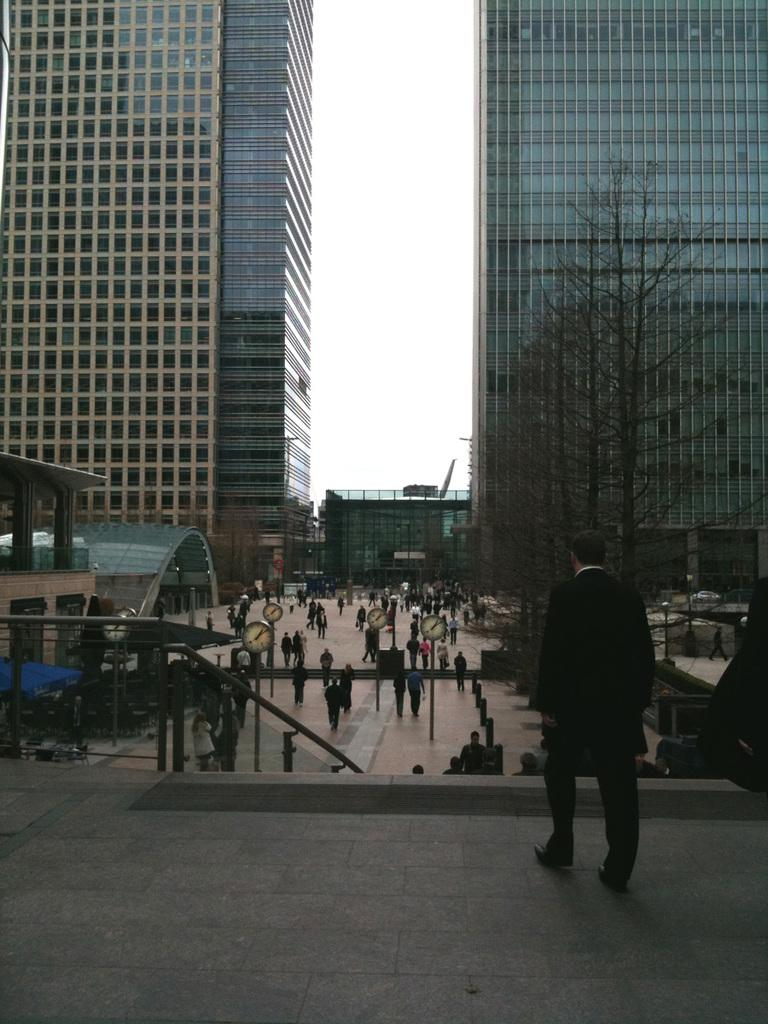What is the man on the right side of the image wearing? The man is wearing a suit and trousers. What type of footwear is the man wearing? The man is wearing shoes. What is the man doing in the image? The man is walking. What can be seen in the middle of the image? There are many people, clocks, a staircase, buildings, trees, and a floor visible in the middle of the image. What is visible in the background of the image? The sky is visible in the image. How does the hen move around in the image? There is no hen present in the image. What is the man doing with his wrist in the image? The man's wrist is not visible in the image, and there is no indication of what he might be doing with it. 